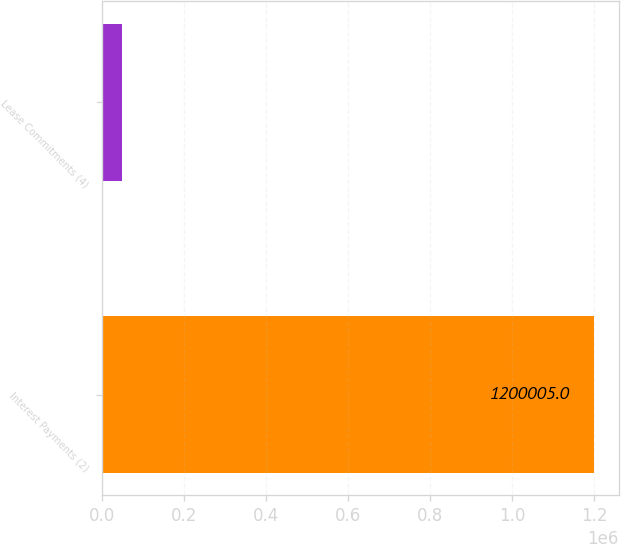Convert chart. <chart><loc_0><loc_0><loc_500><loc_500><bar_chart><fcel>Interest Payments (2)<fcel>Lease Commitments (4)<nl><fcel>1.2e+06<fcel>47947<nl></chart> 